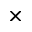<formula> <loc_0><loc_0><loc_500><loc_500>\times</formula> 